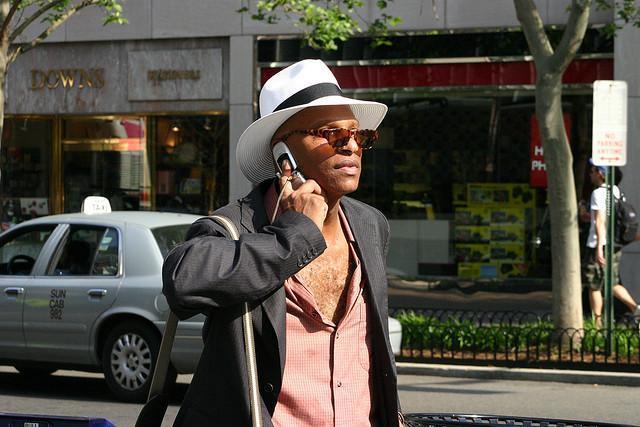How many buttons are done up?
Give a very brief answer. 2. How many people are visible?
Give a very brief answer. 2. 